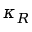Convert formula to latex. <formula><loc_0><loc_0><loc_500><loc_500>\kappa _ { R }</formula> 